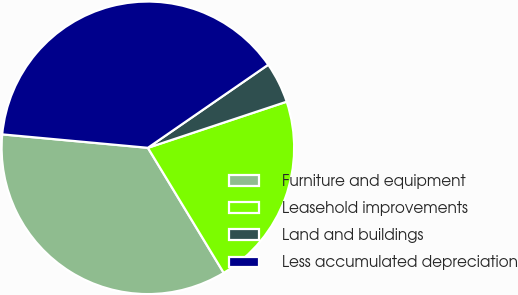<chart> <loc_0><loc_0><loc_500><loc_500><pie_chart><fcel>Furniture and equipment<fcel>Leasehold improvements<fcel>Land and buildings<fcel>Less accumulated depreciation<nl><fcel>35.14%<fcel>21.43%<fcel>4.51%<fcel>38.92%<nl></chart> 